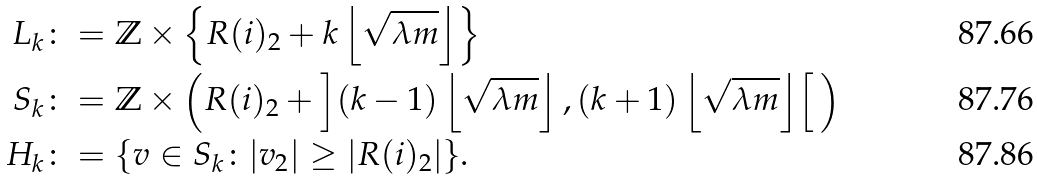Convert formula to latex. <formula><loc_0><loc_0><loc_500><loc_500>L _ { k } & \colon = \mathbb { Z } \times \left \{ R ( i ) _ { 2 } + k \left \lfloor \sqrt { \lambda m } \right \rfloor \right \} \\ S _ { k } & \colon = \mathbb { Z } \times \left ( R ( i ) _ { 2 } + \left ] ( k - 1 ) \left \lfloor \sqrt { \lambda m } \right \rfloor , ( k + 1 ) \left \lfloor \sqrt { \lambda m } \right \rfloor \right [ \, \right ) \\ H _ { k } & \colon = \{ v \in S _ { k } \colon | v _ { 2 } | \geq | R ( i ) _ { 2 } | \} .</formula> 